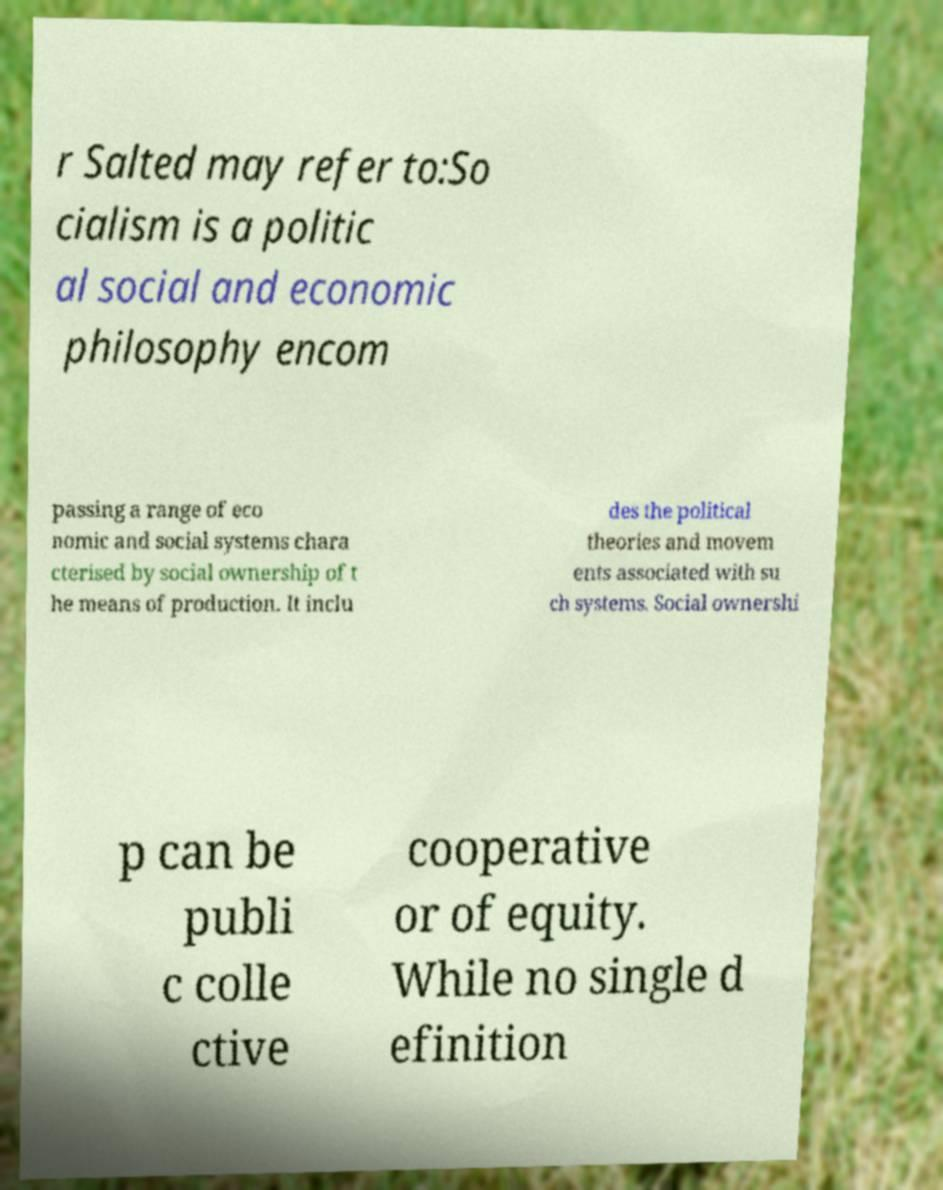Can you read and provide the text displayed in the image?This photo seems to have some interesting text. Can you extract and type it out for me? r Salted may refer to:So cialism is a politic al social and economic philosophy encom passing a range of eco nomic and social systems chara cterised by social ownership of t he means of production. It inclu des the political theories and movem ents associated with su ch systems. Social ownershi p can be publi c colle ctive cooperative or of equity. While no single d efinition 